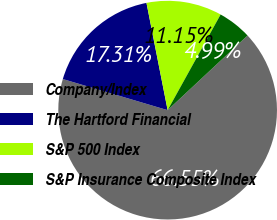Convert chart to OTSL. <chart><loc_0><loc_0><loc_500><loc_500><pie_chart><fcel>Company/Index<fcel>The Hartford Financial<fcel>S&P 500 Index<fcel>S&P Insurance Composite Index<nl><fcel>66.55%<fcel>17.31%<fcel>11.15%<fcel>4.99%<nl></chart> 